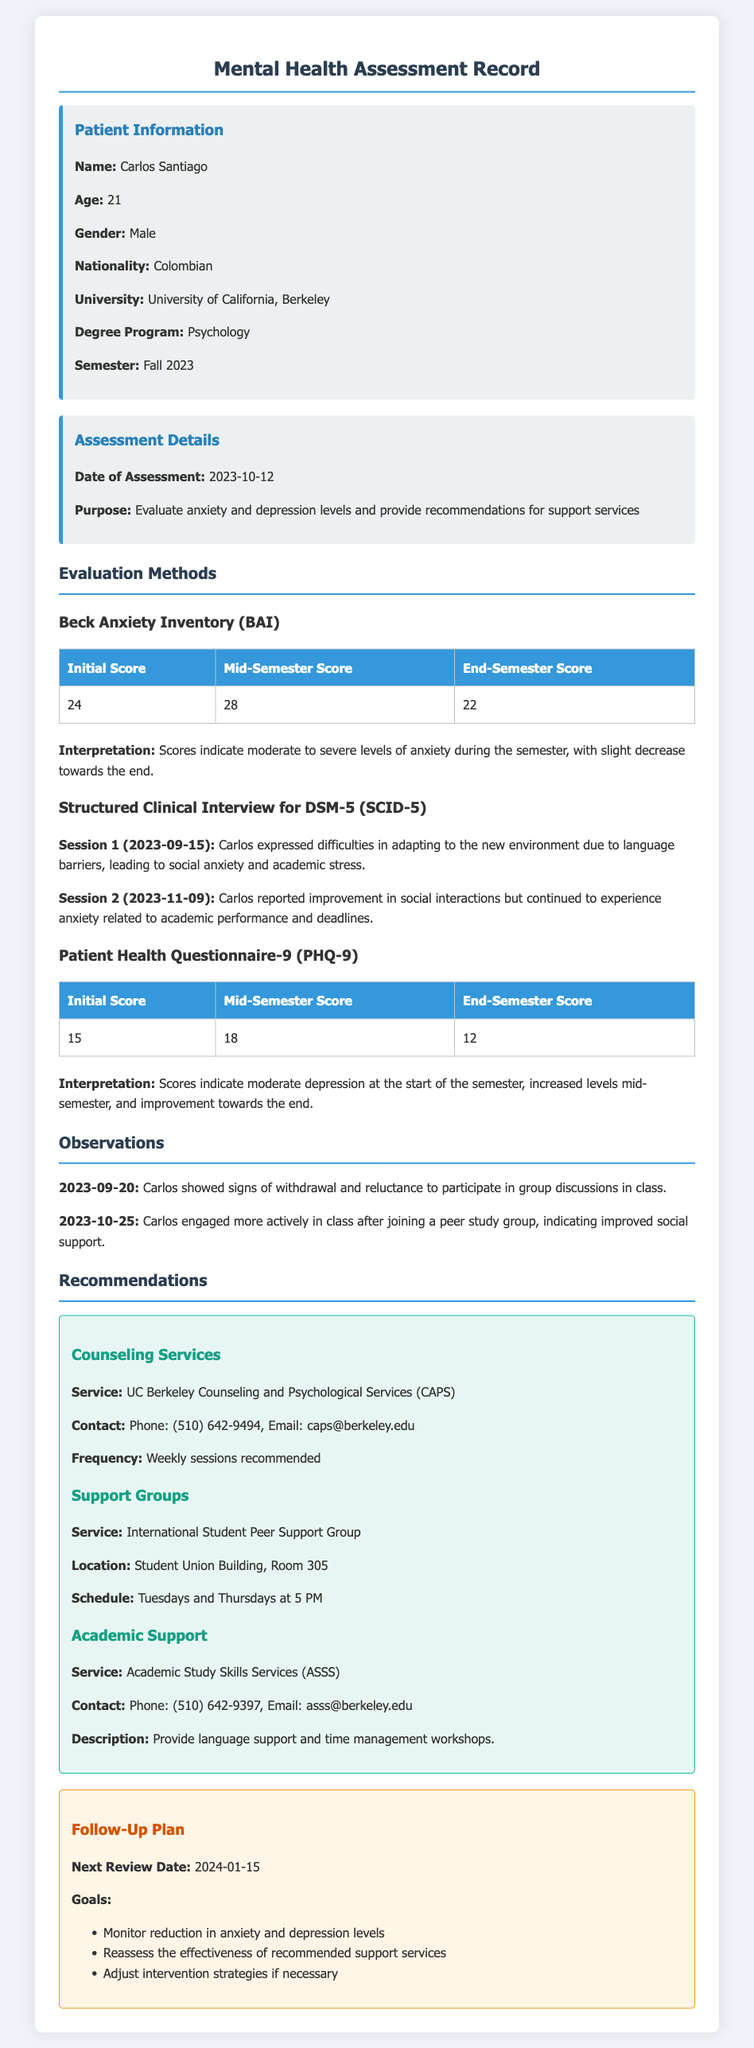What is the name of the patient? The patient's name is provided in the patient information section.
Answer: Carlos Santiago What is the initial anxiety score according to the Beck Anxiety Inventory? The initial score is listed in the assessment section of the document.
Answer: 24 What was the date of the first session for the SCID-5 interview? The date of the first session is mentioned under SCID-5 details.
Answer: 2023-09-15 What service is recommended for counseling support? The document lists specific services and recommendations for support.
Answer: UC Berkeley Counseling and Psychological Services (CAPS) How many sessions are recommended per week for counseling? The recommendation for frequency of sessions is stated in the recommendations section.
Answer: Weekly sessions What improvement did Carlos show by participating in a peer study group? Observations in the document indicate changes in engagement levels.
Answer: Engaged more actively in class What was the end-semester score for the Patient Health Questionnaire-9? The end-semester score is presented in the corresponding table for PHQ-9.
Answer: 12 What is the scheduled meeting time for the International Student Peer Support Group? The schedule for the support group is outlined in the recommendations section.
Answer: Tuesdays and Thursdays at 5 PM What is the next review date for the follow-up plan? The follow-up plan includes specific future dates for reviews.
Answer: 2024-01-15 